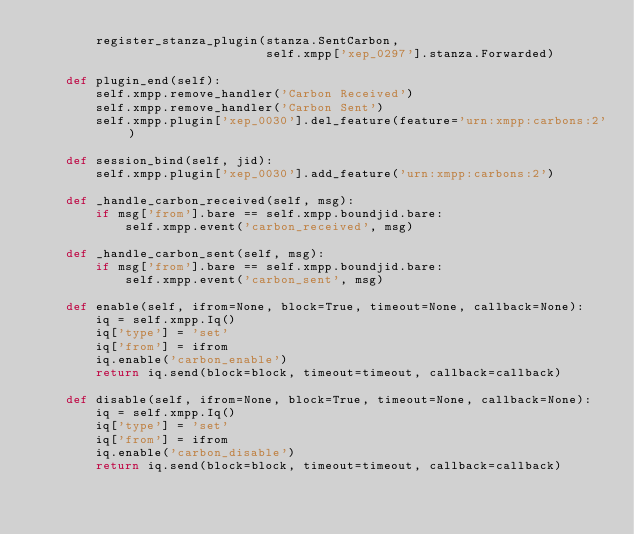<code> <loc_0><loc_0><loc_500><loc_500><_Python_>        register_stanza_plugin(stanza.SentCarbon,
                               self.xmpp['xep_0297'].stanza.Forwarded)

    def plugin_end(self):
        self.xmpp.remove_handler('Carbon Received')
        self.xmpp.remove_handler('Carbon Sent')
        self.xmpp.plugin['xep_0030'].del_feature(feature='urn:xmpp:carbons:2')

    def session_bind(self, jid):
        self.xmpp.plugin['xep_0030'].add_feature('urn:xmpp:carbons:2')

    def _handle_carbon_received(self, msg):
        if msg['from'].bare == self.xmpp.boundjid.bare:
            self.xmpp.event('carbon_received', msg)

    def _handle_carbon_sent(self, msg):
        if msg['from'].bare == self.xmpp.boundjid.bare:
            self.xmpp.event('carbon_sent', msg)

    def enable(self, ifrom=None, block=True, timeout=None, callback=None):
        iq = self.xmpp.Iq()
        iq['type'] = 'set'
        iq['from'] = ifrom
        iq.enable('carbon_enable')
        return iq.send(block=block, timeout=timeout, callback=callback)

    def disable(self, ifrom=None, block=True, timeout=None, callback=None):
        iq = self.xmpp.Iq()
        iq['type'] = 'set'
        iq['from'] = ifrom
        iq.enable('carbon_disable')
        return iq.send(block=block, timeout=timeout, callback=callback)
</code> 